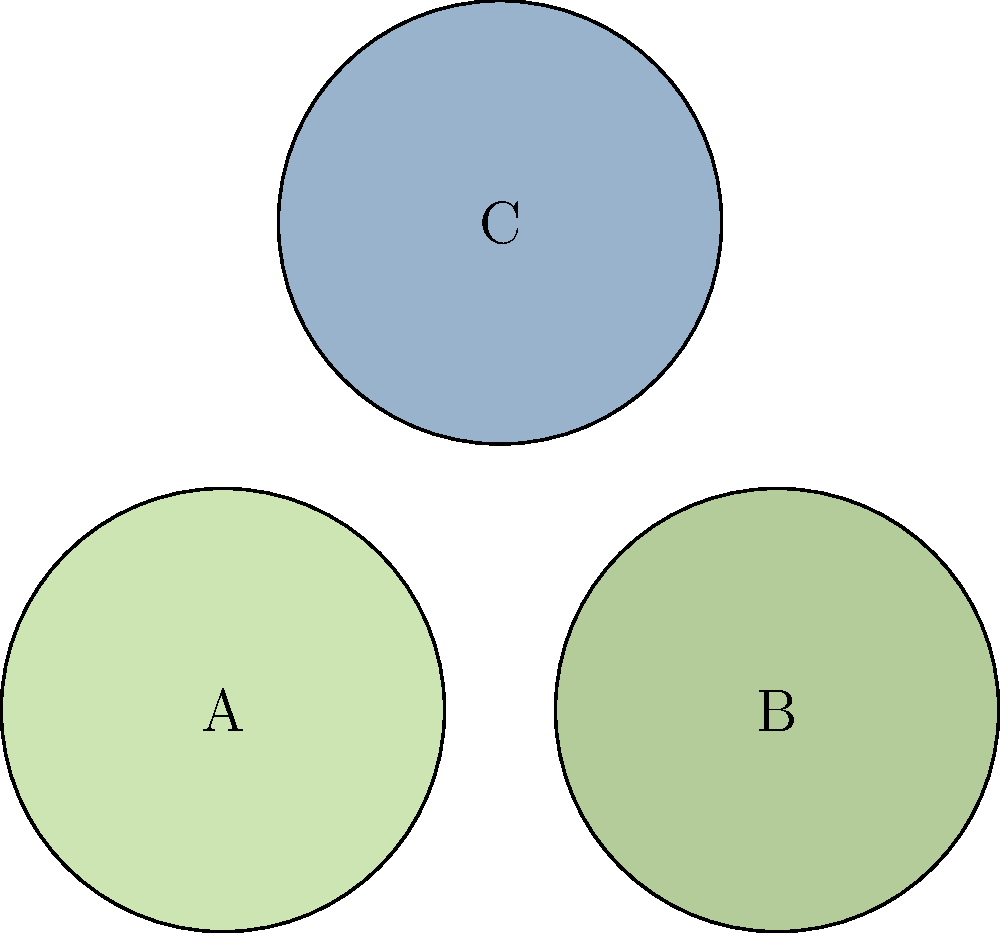The image shows microscope views of three eco-friendly materials used in electric car manufacturing. Which of these materials (A, B, or C) is most likely to be recycled plastic, based on its appearance under the microscope? To identify the recycled plastic material, let's analyze the characteristics of each sample:

1. Material A:
   - Light green color
   - Fibrous structure with long, thin strands
   - Resembles natural plant fibers

2. Material B:
   - Slightly darker green color
   - Also shows a fibrous structure, but with shorter, more varied fibers
   - Appears to be another natural plant-based material

3. Material C:
   - Light blue color
   - Shows a more uniform, less fibrous structure
   - Has small, irregular shapes rather than long fibers

Recycled plastic typically appears more uniform and less fibrous under a microscope compared to natural plant-based materials. It often shows small, irregular shapes due to the melting and reforming process during recycling.

Based on these observations:
- A and B are more likely to be plant-based materials like bamboo or hemp fibers, which are used in eco-friendly car manufacturing for their sustainability.
- C matches the expected appearance of recycled plastic, with its more uniform structure and lack of long fibers.

Therefore, the material most likely to be recycled plastic is C.
Answer: C 